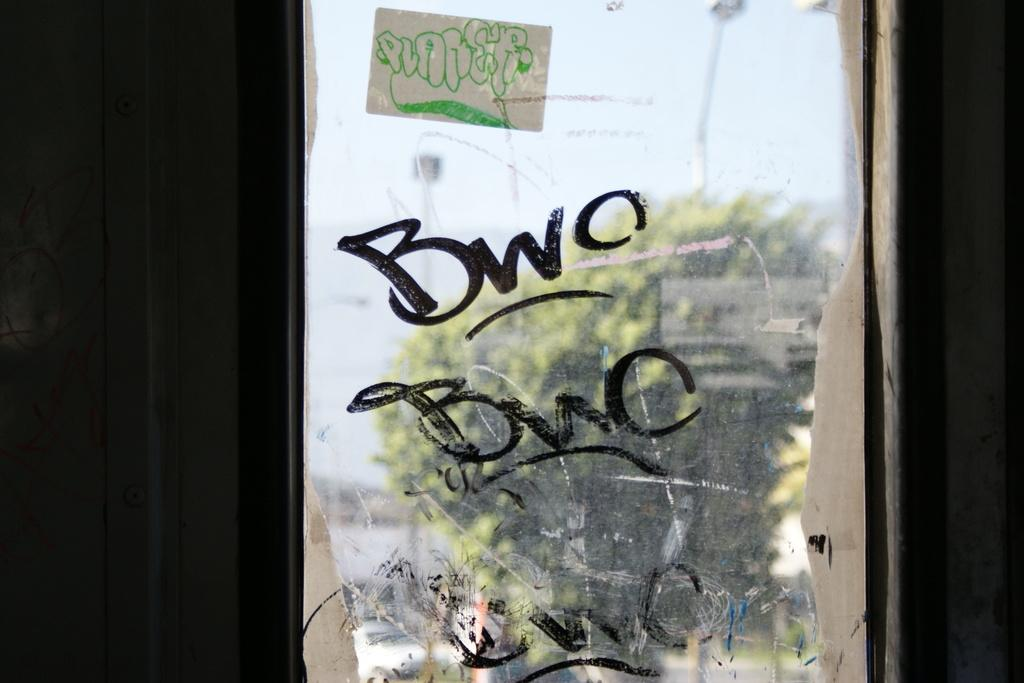What object is present in the image that can hold a liquid? There is a glass in the image that can hold a liquid. What is written on the glass? There is writing on the glass. What type of plant is depicted in the image? There is a tree depicted in the image. What is visible at the top of the image? The sky is visible at the top of the image. What type of apparel is the scarecrow wearing in the image? There is no scarecrow present in the image, so it is not possible to answer that question. 